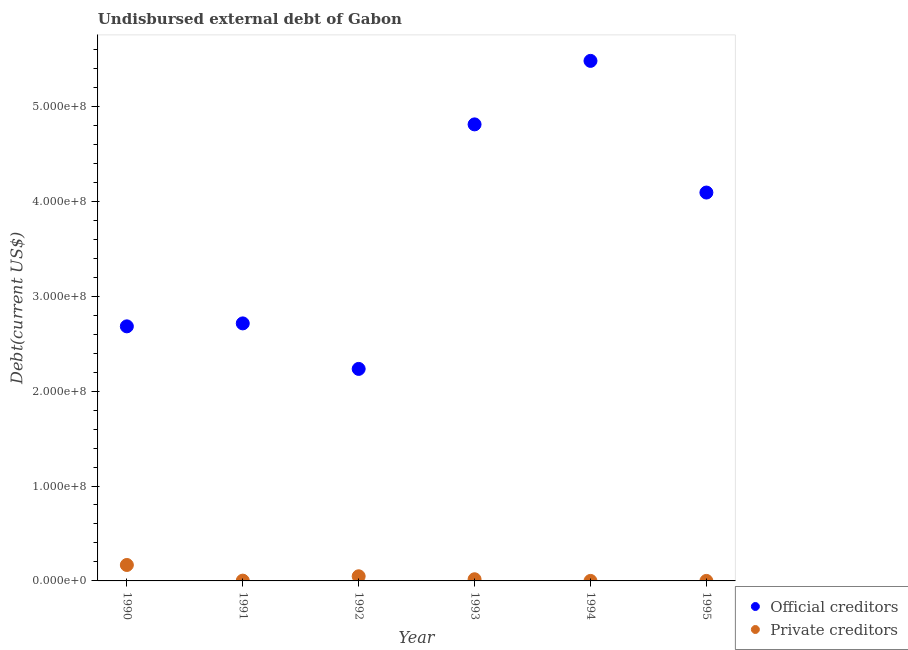How many different coloured dotlines are there?
Your answer should be compact. 2. What is the undisbursed external debt of official creditors in 1993?
Offer a terse response. 4.81e+08. Across all years, what is the maximum undisbursed external debt of official creditors?
Your answer should be compact. 5.48e+08. Across all years, what is the minimum undisbursed external debt of private creditors?
Provide a succinct answer. 10000. In which year was the undisbursed external debt of private creditors maximum?
Your answer should be compact. 1990. What is the total undisbursed external debt of official creditors in the graph?
Your response must be concise. 2.20e+09. What is the difference between the undisbursed external debt of private creditors in 1990 and that in 1994?
Keep it short and to the point. 1.68e+07. What is the difference between the undisbursed external debt of private creditors in 1992 and the undisbursed external debt of official creditors in 1991?
Offer a very short reply. -2.66e+08. What is the average undisbursed external debt of official creditors per year?
Your answer should be compact. 3.67e+08. In the year 1991, what is the difference between the undisbursed external debt of official creditors and undisbursed external debt of private creditors?
Provide a short and direct response. 2.71e+08. What is the ratio of the undisbursed external debt of private creditors in 1990 to that in 1995?
Make the answer very short. 1680.1. Is the difference between the undisbursed external debt of private creditors in 1993 and 1994 greater than the difference between the undisbursed external debt of official creditors in 1993 and 1994?
Provide a short and direct response. Yes. What is the difference between the highest and the second highest undisbursed external debt of private creditors?
Give a very brief answer. 1.19e+07. What is the difference between the highest and the lowest undisbursed external debt of private creditors?
Your answer should be very brief. 1.68e+07. In how many years, is the undisbursed external debt of official creditors greater than the average undisbursed external debt of official creditors taken over all years?
Ensure brevity in your answer.  3. Does the undisbursed external debt of private creditors monotonically increase over the years?
Offer a terse response. No. How many years are there in the graph?
Your answer should be very brief. 6. What is the difference between two consecutive major ticks on the Y-axis?
Provide a short and direct response. 1.00e+08. Are the values on the major ticks of Y-axis written in scientific E-notation?
Give a very brief answer. Yes. Does the graph contain grids?
Provide a succinct answer. No. Where does the legend appear in the graph?
Provide a short and direct response. Bottom right. How many legend labels are there?
Ensure brevity in your answer.  2. How are the legend labels stacked?
Give a very brief answer. Vertical. What is the title of the graph?
Provide a short and direct response. Undisbursed external debt of Gabon. Does "Time to export" appear as one of the legend labels in the graph?
Ensure brevity in your answer.  No. What is the label or title of the X-axis?
Your answer should be compact. Year. What is the label or title of the Y-axis?
Provide a short and direct response. Debt(current US$). What is the Debt(current US$) of Official creditors in 1990?
Ensure brevity in your answer.  2.68e+08. What is the Debt(current US$) in Private creditors in 1990?
Provide a short and direct response. 1.68e+07. What is the Debt(current US$) in Official creditors in 1991?
Give a very brief answer. 2.71e+08. What is the Debt(current US$) in Private creditors in 1991?
Your response must be concise. 3.04e+05. What is the Debt(current US$) in Official creditors in 1992?
Keep it short and to the point. 2.23e+08. What is the Debt(current US$) of Private creditors in 1992?
Provide a succinct answer. 4.90e+06. What is the Debt(current US$) in Official creditors in 1993?
Your answer should be very brief. 4.81e+08. What is the Debt(current US$) of Private creditors in 1993?
Give a very brief answer. 1.76e+06. What is the Debt(current US$) of Official creditors in 1994?
Your answer should be compact. 5.48e+08. What is the Debt(current US$) of Official creditors in 1995?
Your answer should be very brief. 4.09e+08. What is the Debt(current US$) of Private creditors in 1995?
Make the answer very short. 10000. Across all years, what is the maximum Debt(current US$) of Official creditors?
Your answer should be compact. 5.48e+08. Across all years, what is the maximum Debt(current US$) in Private creditors?
Provide a short and direct response. 1.68e+07. Across all years, what is the minimum Debt(current US$) in Official creditors?
Ensure brevity in your answer.  2.23e+08. Across all years, what is the minimum Debt(current US$) in Private creditors?
Your answer should be compact. 10000. What is the total Debt(current US$) in Official creditors in the graph?
Provide a short and direct response. 2.20e+09. What is the total Debt(current US$) in Private creditors in the graph?
Your response must be concise. 2.38e+07. What is the difference between the Debt(current US$) in Official creditors in 1990 and that in 1991?
Offer a terse response. -3.11e+06. What is the difference between the Debt(current US$) in Private creditors in 1990 and that in 1991?
Offer a very short reply. 1.65e+07. What is the difference between the Debt(current US$) of Official creditors in 1990 and that in 1992?
Provide a succinct answer. 4.48e+07. What is the difference between the Debt(current US$) of Private creditors in 1990 and that in 1992?
Provide a succinct answer. 1.19e+07. What is the difference between the Debt(current US$) in Official creditors in 1990 and that in 1993?
Your response must be concise. -2.13e+08. What is the difference between the Debt(current US$) of Private creditors in 1990 and that in 1993?
Provide a succinct answer. 1.50e+07. What is the difference between the Debt(current US$) of Official creditors in 1990 and that in 1994?
Your answer should be very brief. -2.80e+08. What is the difference between the Debt(current US$) in Private creditors in 1990 and that in 1994?
Ensure brevity in your answer.  1.68e+07. What is the difference between the Debt(current US$) of Official creditors in 1990 and that in 1995?
Provide a short and direct response. -1.41e+08. What is the difference between the Debt(current US$) of Private creditors in 1990 and that in 1995?
Provide a short and direct response. 1.68e+07. What is the difference between the Debt(current US$) of Official creditors in 1991 and that in 1992?
Offer a very short reply. 4.80e+07. What is the difference between the Debt(current US$) in Private creditors in 1991 and that in 1992?
Your response must be concise. -4.59e+06. What is the difference between the Debt(current US$) in Official creditors in 1991 and that in 1993?
Provide a succinct answer. -2.10e+08. What is the difference between the Debt(current US$) of Private creditors in 1991 and that in 1993?
Make the answer very short. -1.45e+06. What is the difference between the Debt(current US$) in Official creditors in 1991 and that in 1994?
Give a very brief answer. -2.77e+08. What is the difference between the Debt(current US$) in Private creditors in 1991 and that in 1994?
Provide a short and direct response. 2.94e+05. What is the difference between the Debt(current US$) of Official creditors in 1991 and that in 1995?
Provide a short and direct response. -1.38e+08. What is the difference between the Debt(current US$) of Private creditors in 1991 and that in 1995?
Your response must be concise. 2.94e+05. What is the difference between the Debt(current US$) in Official creditors in 1992 and that in 1993?
Your answer should be compact. -2.58e+08. What is the difference between the Debt(current US$) of Private creditors in 1992 and that in 1993?
Your answer should be very brief. 3.14e+06. What is the difference between the Debt(current US$) in Official creditors in 1992 and that in 1994?
Give a very brief answer. -3.25e+08. What is the difference between the Debt(current US$) in Private creditors in 1992 and that in 1994?
Keep it short and to the point. 4.89e+06. What is the difference between the Debt(current US$) of Official creditors in 1992 and that in 1995?
Provide a short and direct response. -1.86e+08. What is the difference between the Debt(current US$) in Private creditors in 1992 and that in 1995?
Offer a terse response. 4.89e+06. What is the difference between the Debt(current US$) of Official creditors in 1993 and that in 1994?
Provide a succinct answer. -6.69e+07. What is the difference between the Debt(current US$) of Private creditors in 1993 and that in 1994?
Your response must be concise. 1.74e+06. What is the difference between the Debt(current US$) in Official creditors in 1993 and that in 1995?
Your answer should be very brief. 7.18e+07. What is the difference between the Debt(current US$) in Private creditors in 1993 and that in 1995?
Offer a very short reply. 1.74e+06. What is the difference between the Debt(current US$) in Official creditors in 1994 and that in 1995?
Your response must be concise. 1.39e+08. What is the difference between the Debt(current US$) of Official creditors in 1990 and the Debt(current US$) of Private creditors in 1991?
Your response must be concise. 2.68e+08. What is the difference between the Debt(current US$) of Official creditors in 1990 and the Debt(current US$) of Private creditors in 1992?
Provide a succinct answer. 2.63e+08. What is the difference between the Debt(current US$) of Official creditors in 1990 and the Debt(current US$) of Private creditors in 1993?
Keep it short and to the point. 2.66e+08. What is the difference between the Debt(current US$) of Official creditors in 1990 and the Debt(current US$) of Private creditors in 1994?
Keep it short and to the point. 2.68e+08. What is the difference between the Debt(current US$) in Official creditors in 1990 and the Debt(current US$) in Private creditors in 1995?
Keep it short and to the point. 2.68e+08. What is the difference between the Debt(current US$) in Official creditors in 1991 and the Debt(current US$) in Private creditors in 1992?
Ensure brevity in your answer.  2.66e+08. What is the difference between the Debt(current US$) in Official creditors in 1991 and the Debt(current US$) in Private creditors in 1993?
Provide a short and direct response. 2.70e+08. What is the difference between the Debt(current US$) of Official creditors in 1991 and the Debt(current US$) of Private creditors in 1994?
Make the answer very short. 2.71e+08. What is the difference between the Debt(current US$) in Official creditors in 1991 and the Debt(current US$) in Private creditors in 1995?
Your answer should be very brief. 2.71e+08. What is the difference between the Debt(current US$) of Official creditors in 1992 and the Debt(current US$) of Private creditors in 1993?
Give a very brief answer. 2.22e+08. What is the difference between the Debt(current US$) of Official creditors in 1992 and the Debt(current US$) of Private creditors in 1994?
Make the answer very short. 2.23e+08. What is the difference between the Debt(current US$) in Official creditors in 1992 and the Debt(current US$) in Private creditors in 1995?
Your response must be concise. 2.23e+08. What is the difference between the Debt(current US$) in Official creditors in 1993 and the Debt(current US$) in Private creditors in 1994?
Provide a short and direct response. 4.81e+08. What is the difference between the Debt(current US$) of Official creditors in 1993 and the Debt(current US$) of Private creditors in 1995?
Your answer should be compact. 4.81e+08. What is the difference between the Debt(current US$) of Official creditors in 1994 and the Debt(current US$) of Private creditors in 1995?
Provide a succinct answer. 5.48e+08. What is the average Debt(current US$) of Official creditors per year?
Keep it short and to the point. 3.67e+08. What is the average Debt(current US$) in Private creditors per year?
Your answer should be very brief. 3.96e+06. In the year 1990, what is the difference between the Debt(current US$) in Official creditors and Debt(current US$) in Private creditors?
Your answer should be compact. 2.51e+08. In the year 1991, what is the difference between the Debt(current US$) of Official creditors and Debt(current US$) of Private creditors?
Provide a succinct answer. 2.71e+08. In the year 1992, what is the difference between the Debt(current US$) of Official creditors and Debt(current US$) of Private creditors?
Offer a terse response. 2.18e+08. In the year 1993, what is the difference between the Debt(current US$) in Official creditors and Debt(current US$) in Private creditors?
Your answer should be very brief. 4.79e+08. In the year 1994, what is the difference between the Debt(current US$) of Official creditors and Debt(current US$) of Private creditors?
Offer a terse response. 5.48e+08. In the year 1995, what is the difference between the Debt(current US$) in Official creditors and Debt(current US$) in Private creditors?
Your response must be concise. 4.09e+08. What is the ratio of the Debt(current US$) of Official creditors in 1990 to that in 1991?
Your response must be concise. 0.99. What is the ratio of the Debt(current US$) in Private creditors in 1990 to that in 1991?
Ensure brevity in your answer.  55.27. What is the ratio of the Debt(current US$) in Official creditors in 1990 to that in 1992?
Offer a terse response. 1.2. What is the ratio of the Debt(current US$) in Private creditors in 1990 to that in 1992?
Ensure brevity in your answer.  3.43. What is the ratio of the Debt(current US$) of Official creditors in 1990 to that in 1993?
Your answer should be very brief. 0.56. What is the ratio of the Debt(current US$) in Private creditors in 1990 to that in 1993?
Keep it short and to the point. 9.57. What is the ratio of the Debt(current US$) in Official creditors in 1990 to that in 1994?
Your response must be concise. 0.49. What is the ratio of the Debt(current US$) of Private creditors in 1990 to that in 1994?
Offer a terse response. 1680.1. What is the ratio of the Debt(current US$) in Official creditors in 1990 to that in 1995?
Offer a very short reply. 0.66. What is the ratio of the Debt(current US$) in Private creditors in 1990 to that in 1995?
Offer a very short reply. 1680.1. What is the ratio of the Debt(current US$) of Official creditors in 1991 to that in 1992?
Give a very brief answer. 1.21. What is the ratio of the Debt(current US$) of Private creditors in 1991 to that in 1992?
Make the answer very short. 0.06. What is the ratio of the Debt(current US$) of Official creditors in 1991 to that in 1993?
Offer a very short reply. 0.56. What is the ratio of the Debt(current US$) of Private creditors in 1991 to that in 1993?
Offer a very short reply. 0.17. What is the ratio of the Debt(current US$) in Official creditors in 1991 to that in 1994?
Give a very brief answer. 0.5. What is the ratio of the Debt(current US$) of Private creditors in 1991 to that in 1994?
Provide a succinct answer. 30.4. What is the ratio of the Debt(current US$) of Official creditors in 1991 to that in 1995?
Keep it short and to the point. 0.66. What is the ratio of the Debt(current US$) in Private creditors in 1991 to that in 1995?
Ensure brevity in your answer.  30.4. What is the ratio of the Debt(current US$) of Official creditors in 1992 to that in 1993?
Your response must be concise. 0.46. What is the ratio of the Debt(current US$) in Private creditors in 1992 to that in 1993?
Ensure brevity in your answer.  2.79. What is the ratio of the Debt(current US$) in Official creditors in 1992 to that in 1994?
Provide a short and direct response. 0.41. What is the ratio of the Debt(current US$) of Private creditors in 1992 to that in 1994?
Provide a succinct answer. 489.7. What is the ratio of the Debt(current US$) of Official creditors in 1992 to that in 1995?
Your answer should be very brief. 0.55. What is the ratio of the Debt(current US$) of Private creditors in 1992 to that in 1995?
Your answer should be compact. 489.7. What is the ratio of the Debt(current US$) in Official creditors in 1993 to that in 1994?
Keep it short and to the point. 0.88. What is the ratio of the Debt(current US$) in Private creditors in 1993 to that in 1994?
Make the answer very short. 175.5. What is the ratio of the Debt(current US$) in Official creditors in 1993 to that in 1995?
Your response must be concise. 1.18. What is the ratio of the Debt(current US$) of Private creditors in 1993 to that in 1995?
Offer a very short reply. 175.5. What is the ratio of the Debt(current US$) in Official creditors in 1994 to that in 1995?
Your answer should be compact. 1.34. What is the difference between the highest and the second highest Debt(current US$) in Official creditors?
Make the answer very short. 6.69e+07. What is the difference between the highest and the second highest Debt(current US$) of Private creditors?
Ensure brevity in your answer.  1.19e+07. What is the difference between the highest and the lowest Debt(current US$) of Official creditors?
Provide a short and direct response. 3.25e+08. What is the difference between the highest and the lowest Debt(current US$) of Private creditors?
Your response must be concise. 1.68e+07. 